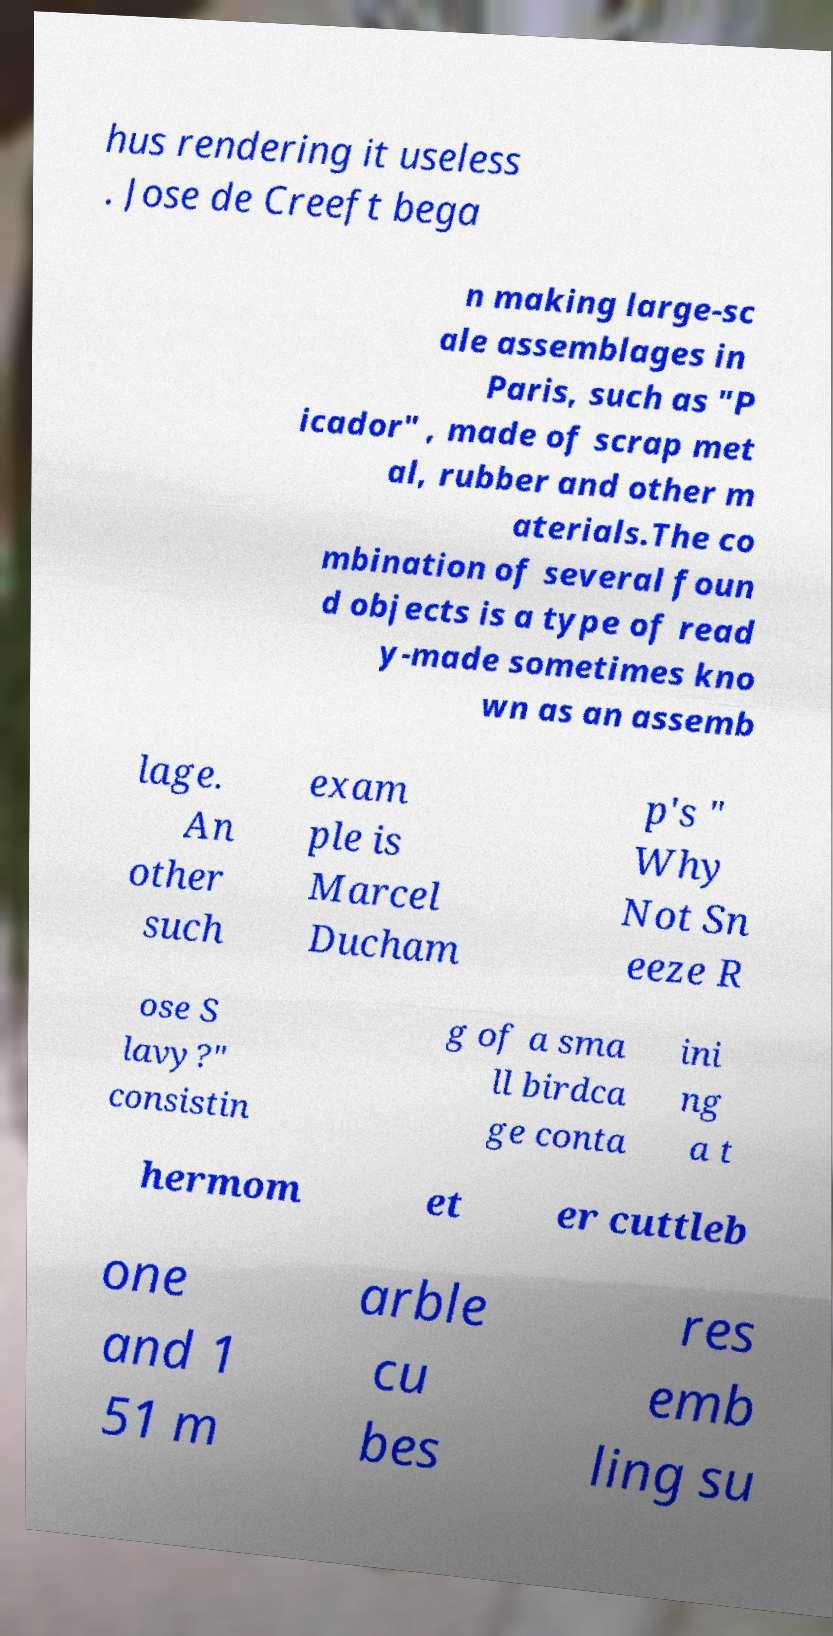Could you assist in decoding the text presented in this image and type it out clearly? hus rendering it useless . Jose de Creeft bega n making large-sc ale assemblages in Paris, such as "P icador" , made of scrap met al, rubber and other m aterials.The co mbination of several foun d objects is a type of read y-made sometimes kno wn as an assemb lage. An other such exam ple is Marcel Ducham p's " Why Not Sn eeze R ose S lavy?" consistin g of a sma ll birdca ge conta ini ng a t hermom et er cuttleb one and 1 51 m arble cu bes res emb ling su 